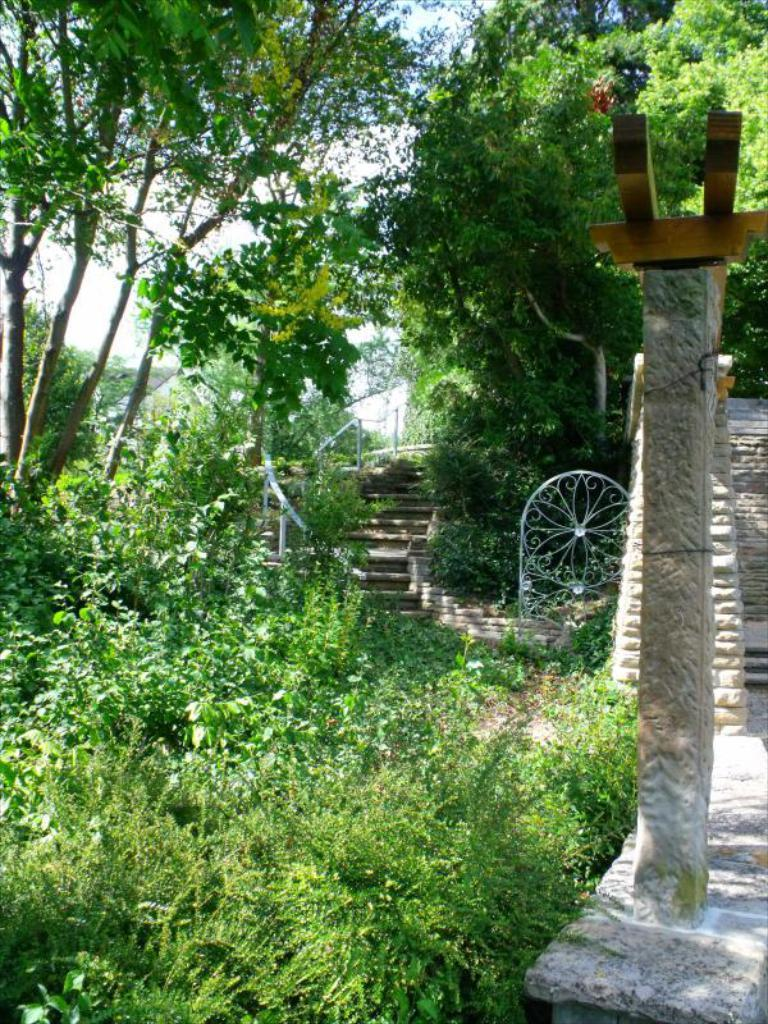What type of vegetation is on the left side of the image? There are plants on the left side of the image. What architectural feature can be seen in the background of the image? There are stairs in the background of the image. What other type of vegetation is visible in the image? There are trees visible in the image. What is the condition of the sky in the image? The sky is clear in the image. What type of insurance is being discussed in the image? There is no discussion of insurance in the image; it features plants, stairs, trees, and a clear sky. What color are the trousers being worn by the person in the image? There is no person present in the image, so it is not possible to determine the color of their trousers. 